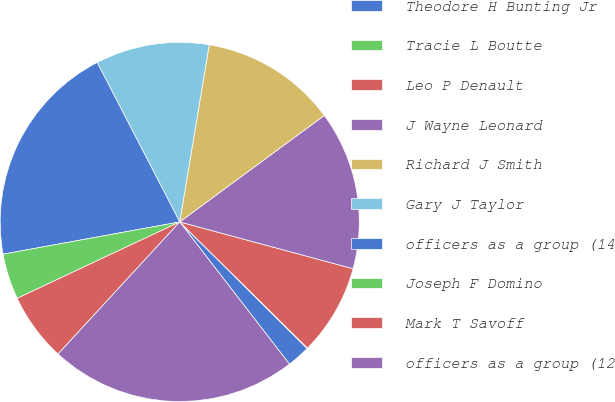Convert chart. <chart><loc_0><loc_0><loc_500><loc_500><pie_chart><fcel>Theodore H Bunting Jr<fcel>Tracie L Boutte<fcel>Leo P Denault<fcel>J Wayne Leonard<fcel>Richard J Smith<fcel>Gary J Taylor<fcel>officers as a group (14<fcel>Joseph F Domino<fcel>Mark T Savoff<fcel>officers as a group (12<nl><fcel>2.09%<fcel>0.05%<fcel>8.2%<fcel>14.3%<fcel>12.27%<fcel>10.23%<fcel>20.27%<fcel>4.12%<fcel>6.16%<fcel>22.31%<nl></chart> 